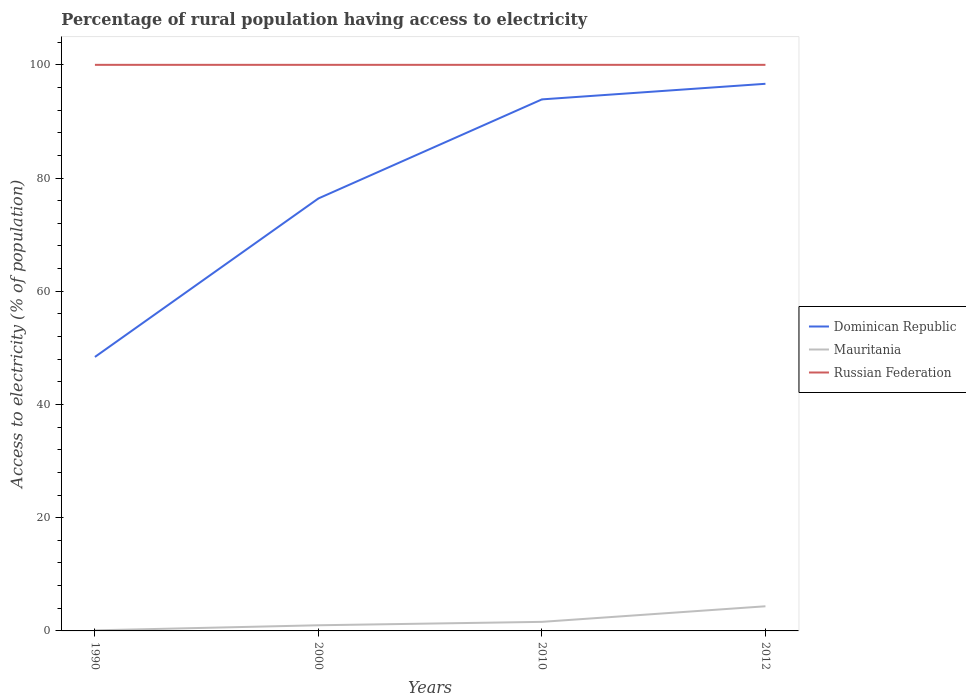How many different coloured lines are there?
Offer a terse response. 3. Does the line corresponding to Russian Federation intersect with the line corresponding to Dominican Republic?
Your answer should be compact. No. Across all years, what is the maximum percentage of rural population having access to electricity in Russian Federation?
Provide a short and direct response. 100. What is the difference between the highest and the second highest percentage of rural population having access to electricity in Dominican Republic?
Offer a terse response. 48.25. How many lines are there?
Ensure brevity in your answer.  3. Does the graph contain any zero values?
Offer a very short reply. No. Does the graph contain grids?
Your answer should be compact. No. What is the title of the graph?
Offer a terse response. Percentage of rural population having access to electricity. What is the label or title of the Y-axis?
Ensure brevity in your answer.  Access to electricity (% of population). What is the Access to electricity (% of population) of Dominican Republic in 1990?
Provide a succinct answer. 48.4. What is the Access to electricity (% of population) of Mauritania in 1990?
Offer a very short reply. 0.1. What is the Access to electricity (% of population) of Russian Federation in 1990?
Offer a terse response. 100. What is the Access to electricity (% of population) of Dominican Republic in 2000?
Keep it short and to the point. 76.4. What is the Access to electricity (% of population) in Russian Federation in 2000?
Your response must be concise. 100. What is the Access to electricity (% of population) of Dominican Republic in 2010?
Ensure brevity in your answer.  93.9. What is the Access to electricity (% of population) of Mauritania in 2010?
Make the answer very short. 1.6. What is the Access to electricity (% of population) in Russian Federation in 2010?
Your response must be concise. 100. What is the Access to electricity (% of population) in Dominican Republic in 2012?
Offer a very short reply. 96.65. What is the Access to electricity (% of population) in Mauritania in 2012?
Offer a terse response. 4.35. Across all years, what is the maximum Access to electricity (% of population) in Dominican Republic?
Provide a succinct answer. 96.65. Across all years, what is the maximum Access to electricity (% of population) in Mauritania?
Your answer should be compact. 4.35. Across all years, what is the maximum Access to electricity (% of population) of Russian Federation?
Your answer should be compact. 100. Across all years, what is the minimum Access to electricity (% of population) of Dominican Republic?
Your answer should be compact. 48.4. Across all years, what is the minimum Access to electricity (% of population) of Russian Federation?
Your answer should be compact. 100. What is the total Access to electricity (% of population) of Dominican Republic in the graph?
Your response must be concise. 315.35. What is the total Access to electricity (% of population) of Mauritania in the graph?
Your response must be concise. 7.05. What is the total Access to electricity (% of population) in Russian Federation in the graph?
Keep it short and to the point. 400. What is the difference between the Access to electricity (% of population) of Dominican Republic in 1990 and that in 2000?
Provide a short and direct response. -28. What is the difference between the Access to electricity (% of population) of Russian Federation in 1990 and that in 2000?
Offer a terse response. 0. What is the difference between the Access to electricity (% of population) of Dominican Republic in 1990 and that in 2010?
Give a very brief answer. -45.5. What is the difference between the Access to electricity (% of population) in Mauritania in 1990 and that in 2010?
Give a very brief answer. -1.5. What is the difference between the Access to electricity (% of population) of Dominican Republic in 1990 and that in 2012?
Provide a short and direct response. -48.25. What is the difference between the Access to electricity (% of population) in Mauritania in 1990 and that in 2012?
Give a very brief answer. -4.25. What is the difference between the Access to electricity (% of population) in Dominican Republic in 2000 and that in 2010?
Offer a terse response. -17.5. What is the difference between the Access to electricity (% of population) of Mauritania in 2000 and that in 2010?
Offer a very short reply. -0.6. What is the difference between the Access to electricity (% of population) in Russian Federation in 2000 and that in 2010?
Your response must be concise. 0. What is the difference between the Access to electricity (% of population) of Dominican Republic in 2000 and that in 2012?
Make the answer very short. -20.25. What is the difference between the Access to electricity (% of population) in Mauritania in 2000 and that in 2012?
Your response must be concise. -3.35. What is the difference between the Access to electricity (% of population) of Russian Federation in 2000 and that in 2012?
Provide a short and direct response. 0. What is the difference between the Access to electricity (% of population) of Dominican Republic in 2010 and that in 2012?
Offer a terse response. -2.75. What is the difference between the Access to electricity (% of population) of Mauritania in 2010 and that in 2012?
Offer a very short reply. -2.75. What is the difference between the Access to electricity (% of population) of Russian Federation in 2010 and that in 2012?
Offer a terse response. 0. What is the difference between the Access to electricity (% of population) in Dominican Republic in 1990 and the Access to electricity (% of population) in Mauritania in 2000?
Offer a terse response. 47.4. What is the difference between the Access to electricity (% of population) in Dominican Republic in 1990 and the Access to electricity (% of population) in Russian Federation in 2000?
Your answer should be very brief. -51.6. What is the difference between the Access to electricity (% of population) of Mauritania in 1990 and the Access to electricity (% of population) of Russian Federation in 2000?
Keep it short and to the point. -99.9. What is the difference between the Access to electricity (% of population) in Dominican Republic in 1990 and the Access to electricity (% of population) in Mauritania in 2010?
Offer a terse response. 46.8. What is the difference between the Access to electricity (% of population) of Dominican Republic in 1990 and the Access to electricity (% of population) of Russian Federation in 2010?
Offer a terse response. -51.6. What is the difference between the Access to electricity (% of population) of Mauritania in 1990 and the Access to electricity (% of population) of Russian Federation in 2010?
Provide a succinct answer. -99.9. What is the difference between the Access to electricity (% of population) of Dominican Republic in 1990 and the Access to electricity (% of population) of Mauritania in 2012?
Your answer should be compact. 44.05. What is the difference between the Access to electricity (% of population) in Dominican Republic in 1990 and the Access to electricity (% of population) in Russian Federation in 2012?
Ensure brevity in your answer.  -51.6. What is the difference between the Access to electricity (% of population) in Mauritania in 1990 and the Access to electricity (% of population) in Russian Federation in 2012?
Make the answer very short. -99.9. What is the difference between the Access to electricity (% of population) of Dominican Republic in 2000 and the Access to electricity (% of population) of Mauritania in 2010?
Your answer should be compact. 74.8. What is the difference between the Access to electricity (% of population) in Dominican Republic in 2000 and the Access to electricity (% of population) in Russian Federation in 2010?
Make the answer very short. -23.6. What is the difference between the Access to electricity (% of population) in Mauritania in 2000 and the Access to electricity (% of population) in Russian Federation in 2010?
Make the answer very short. -99. What is the difference between the Access to electricity (% of population) in Dominican Republic in 2000 and the Access to electricity (% of population) in Mauritania in 2012?
Give a very brief answer. 72.05. What is the difference between the Access to electricity (% of population) of Dominican Republic in 2000 and the Access to electricity (% of population) of Russian Federation in 2012?
Ensure brevity in your answer.  -23.6. What is the difference between the Access to electricity (% of population) of Mauritania in 2000 and the Access to electricity (% of population) of Russian Federation in 2012?
Give a very brief answer. -99. What is the difference between the Access to electricity (% of population) of Dominican Republic in 2010 and the Access to electricity (% of population) of Mauritania in 2012?
Ensure brevity in your answer.  89.55. What is the difference between the Access to electricity (% of population) of Dominican Republic in 2010 and the Access to electricity (% of population) of Russian Federation in 2012?
Provide a succinct answer. -6.1. What is the difference between the Access to electricity (% of population) of Mauritania in 2010 and the Access to electricity (% of population) of Russian Federation in 2012?
Your response must be concise. -98.4. What is the average Access to electricity (% of population) in Dominican Republic per year?
Keep it short and to the point. 78.84. What is the average Access to electricity (% of population) in Mauritania per year?
Keep it short and to the point. 1.76. What is the average Access to electricity (% of population) of Russian Federation per year?
Give a very brief answer. 100. In the year 1990, what is the difference between the Access to electricity (% of population) of Dominican Republic and Access to electricity (% of population) of Mauritania?
Keep it short and to the point. 48.3. In the year 1990, what is the difference between the Access to electricity (% of population) of Dominican Republic and Access to electricity (% of population) of Russian Federation?
Provide a short and direct response. -51.6. In the year 1990, what is the difference between the Access to electricity (% of population) of Mauritania and Access to electricity (% of population) of Russian Federation?
Your response must be concise. -99.9. In the year 2000, what is the difference between the Access to electricity (% of population) in Dominican Republic and Access to electricity (% of population) in Mauritania?
Make the answer very short. 75.4. In the year 2000, what is the difference between the Access to electricity (% of population) in Dominican Republic and Access to electricity (% of population) in Russian Federation?
Give a very brief answer. -23.6. In the year 2000, what is the difference between the Access to electricity (% of population) in Mauritania and Access to electricity (% of population) in Russian Federation?
Make the answer very short. -99. In the year 2010, what is the difference between the Access to electricity (% of population) of Dominican Republic and Access to electricity (% of population) of Mauritania?
Ensure brevity in your answer.  92.3. In the year 2010, what is the difference between the Access to electricity (% of population) in Dominican Republic and Access to electricity (% of population) in Russian Federation?
Keep it short and to the point. -6.1. In the year 2010, what is the difference between the Access to electricity (% of population) of Mauritania and Access to electricity (% of population) of Russian Federation?
Offer a terse response. -98.4. In the year 2012, what is the difference between the Access to electricity (% of population) in Dominican Republic and Access to electricity (% of population) in Mauritania?
Your response must be concise. 92.3. In the year 2012, what is the difference between the Access to electricity (% of population) in Dominican Republic and Access to electricity (% of population) in Russian Federation?
Offer a terse response. -3.35. In the year 2012, what is the difference between the Access to electricity (% of population) of Mauritania and Access to electricity (% of population) of Russian Federation?
Your answer should be compact. -95.65. What is the ratio of the Access to electricity (% of population) of Dominican Republic in 1990 to that in 2000?
Provide a succinct answer. 0.63. What is the ratio of the Access to electricity (% of population) in Russian Federation in 1990 to that in 2000?
Your response must be concise. 1. What is the ratio of the Access to electricity (% of population) of Dominican Republic in 1990 to that in 2010?
Provide a short and direct response. 0.52. What is the ratio of the Access to electricity (% of population) in Mauritania in 1990 to that in 2010?
Provide a succinct answer. 0.06. What is the ratio of the Access to electricity (% of population) of Russian Federation in 1990 to that in 2010?
Your answer should be very brief. 1. What is the ratio of the Access to electricity (% of population) in Dominican Republic in 1990 to that in 2012?
Offer a terse response. 0.5. What is the ratio of the Access to electricity (% of population) of Mauritania in 1990 to that in 2012?
Make the answer very short. 0.02. What is the ratio of the Access to electricity (% of population) in Russian Federation in 1990 to that in 2012?
Give a very brief answer. 1. What is the ratio of the Access to electricity (% of population) in Dominican Republic in 2000 to that in 2010?
Provide a succinct answer. 0.81. What is the ratio of the Access to electricity (% of population) in Russian Federation in 2000 to that in 2010?
Make the answer very short. 1. What is the ratio of the Access to electricity (% of population) of Dominican Republic in 2000 to that in 2012?
Make the answer very short. 0.79. What is the ratio of the Access to electricity (% of population) in Mauritania in 2000 to that in 2012?
Offer a very short reply. 0.23. What is the ratio of the Access to electricity (% of population) of Dominican Republic in 2010 to that in 2012?
Your response must be concise. 0.97. What is the ratio of the Access to electricity (% of population) of Mauritania in 2010 to that in 2012?
Offer a terse response. 0.37. What is the difference between the highest and the second highest Access to electricity (% of population) of Dominican Republic?
Provide a succinct answer. 2.75. What is the difference between the highest and the second highest Access to electricity (% of population) of Mauritania?
Give a very brief answer. 2.75. What is the difference between the highest and the second highest Access to electricity (% of population) in Russian Federation?
Provide a short and direct response. 0. What is the difference between the highest and the lowest Access to electricity (% of population) in Dominican Republic?
Keep it short and to the point. 48.25. What is the difference between the highest and the lowest Access to electricity (% of population) of Mauritania?
Make the answer very short. 4.25. What is the difference between the highest and the lowest Access to electricity (% of population) in Russian Federation?
Offer a very short reply. 0. 